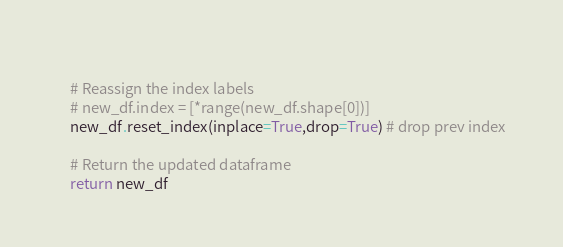Convert code to text. <code><loc_0><loc_0><loc_500><loc_500><_Python_>   
    # Reassign the index labels
    # new_df.index = [*range(new_df.shape[0])]
    new_df.reset_index(inplace=True,drop=True) # drop prev index
   
    # Return the updated dataframe
    return new_df
</code> 